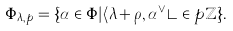Convert formula to latex. <formula><loc_0><loc_0><loc_500><loc_500>\Phi _ { \lambda , p } = \{ \alpha \in \Phi | \langle \lambda + \rho , \alpha ^ { \vee } \rangle \in p \mathbb { Z } \} .</formula> 